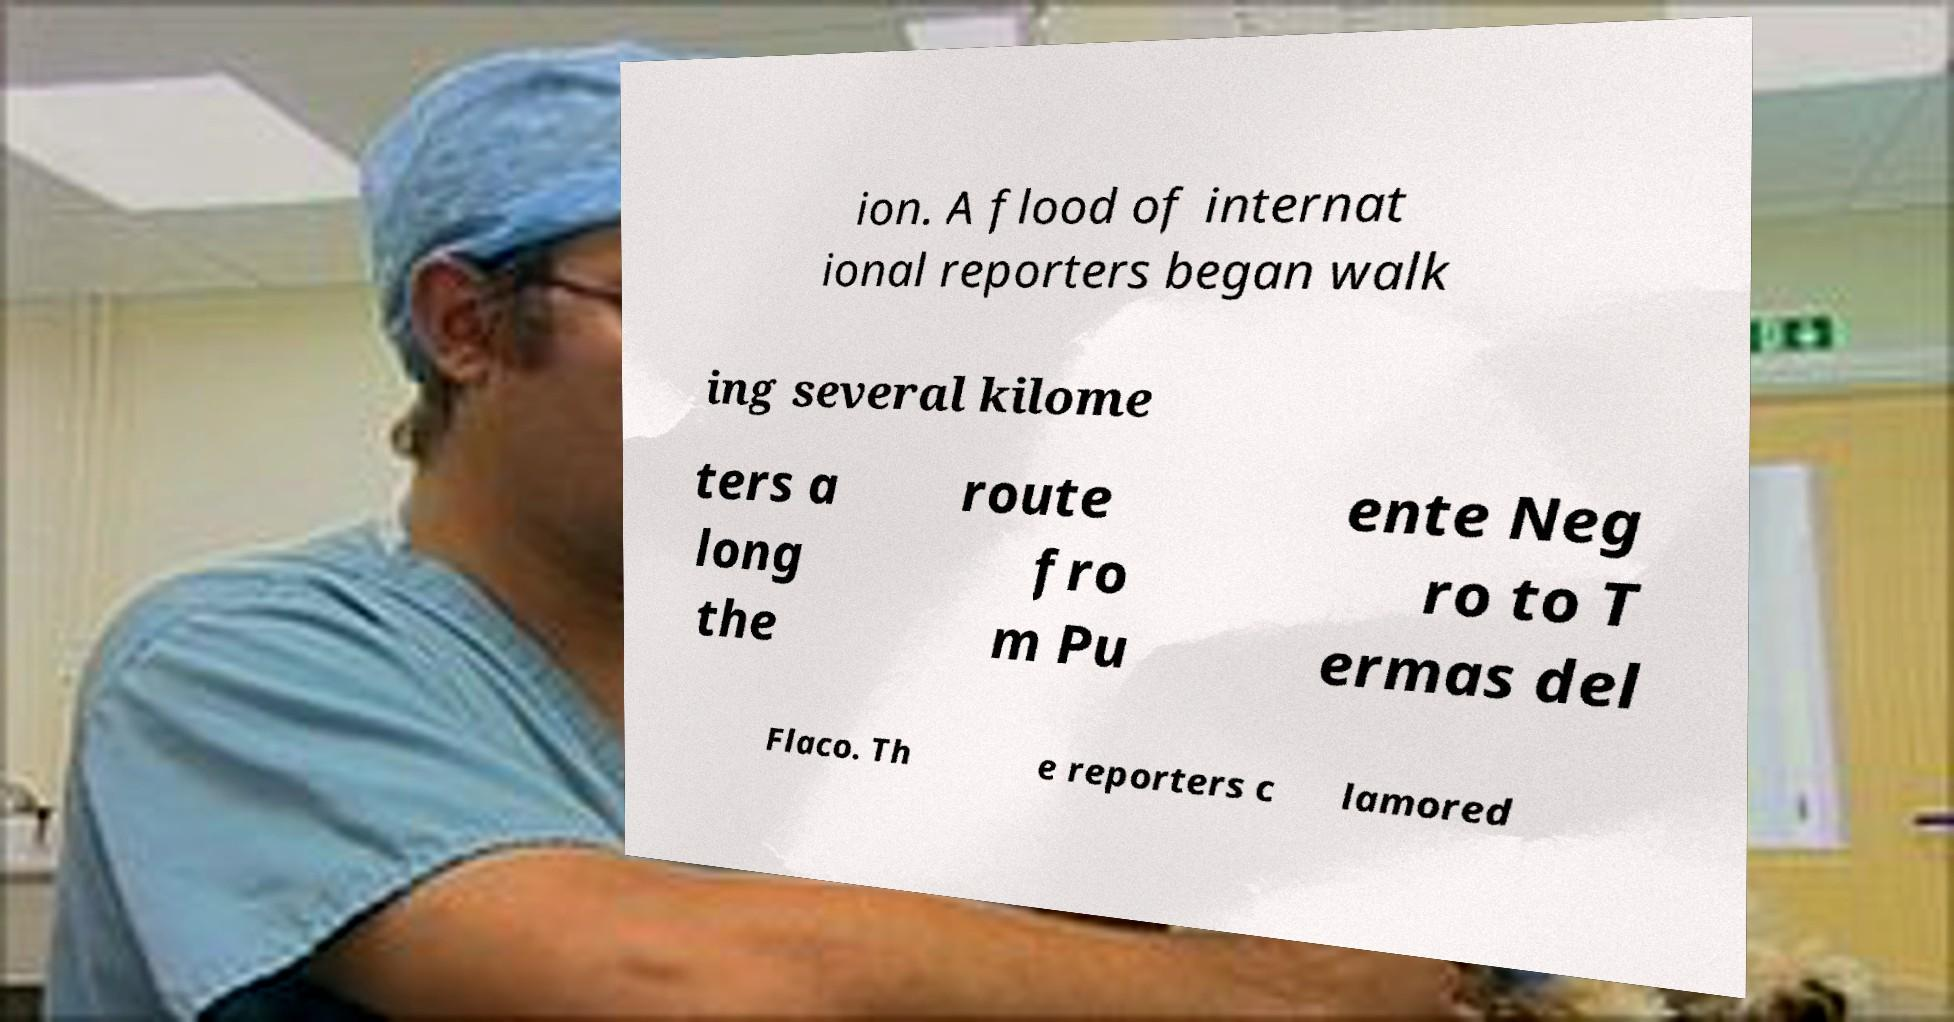Can you read and provide the text displayed in the image?This photo seems to have some interesting text. Can you extract and type it out for me? ion. A flood of internat ional reporters began walk ing several kilome ters a long the route fro m Pu ente Neg ro to T ermas del Flaco. Th e reporters c lamored 